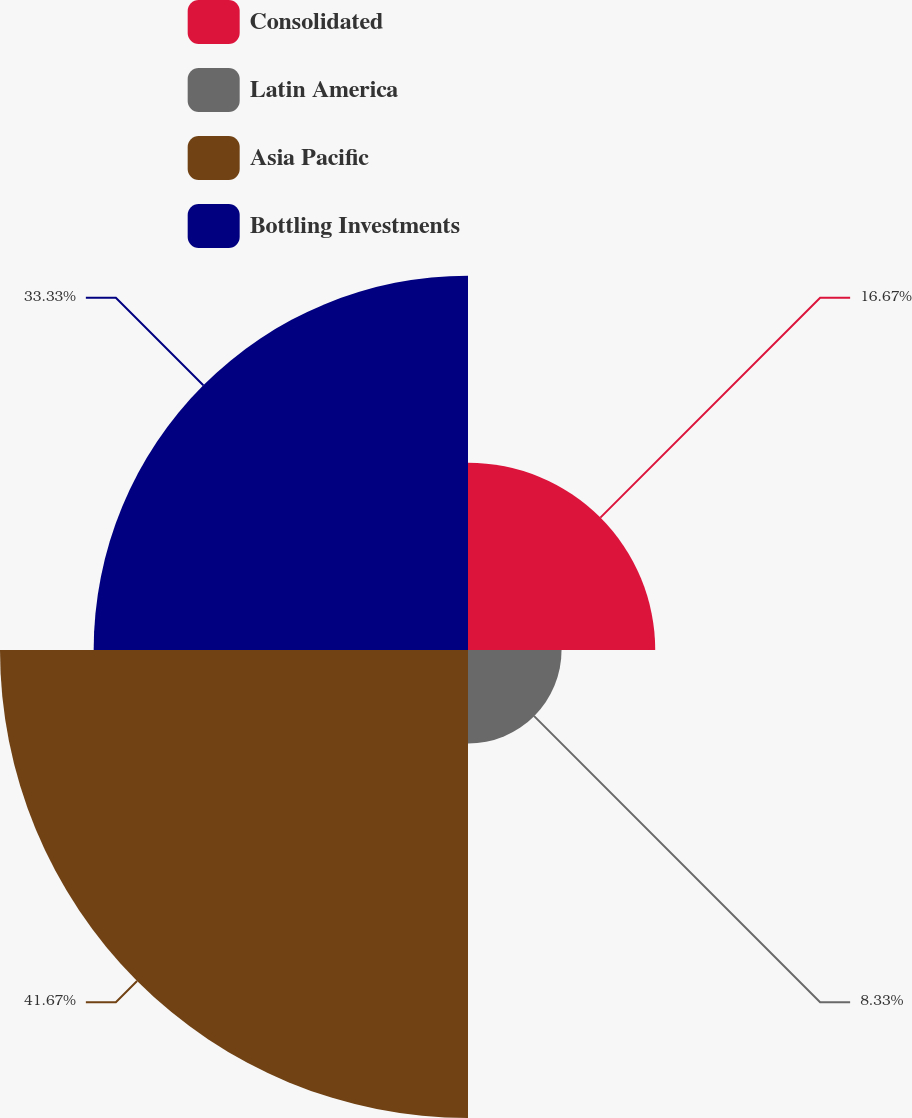Convert chart to OTSL. <chart><loc_0><loc_0><loc_500><loc_500><pie_chart><fcel>Consolidated<fcel>Latin America<fcel>Asia Pacific<fcel>Bottling Investments<nl><fcel>16.67%<fcel>8.33%<fcel>41.67%<fcel>33.33%<nl></chart> 